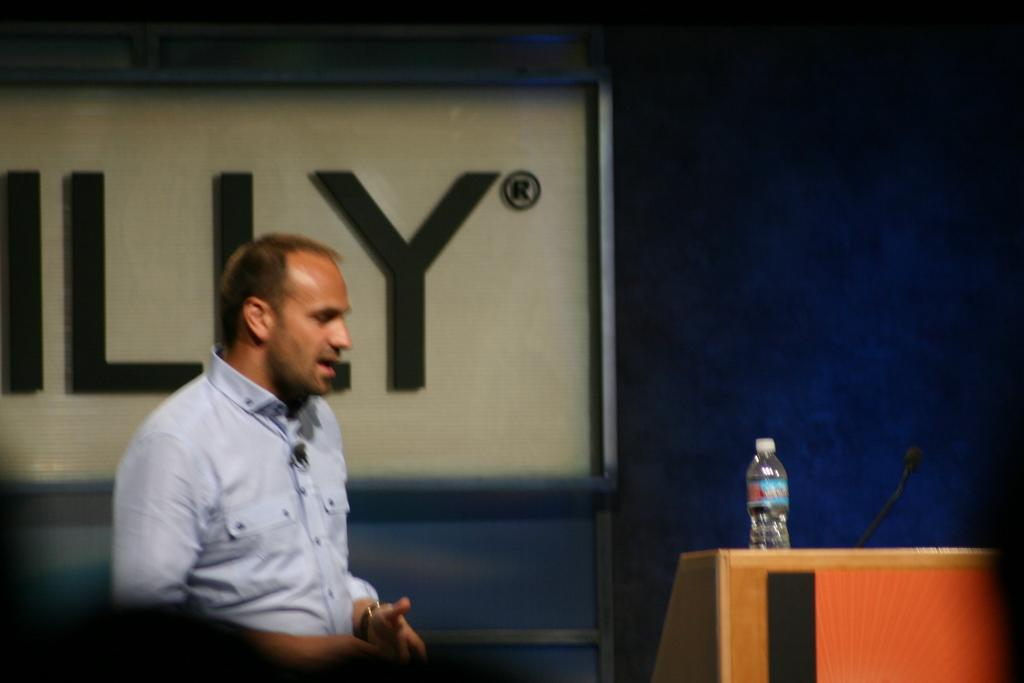What is the main subject of the image? There is a man standing in the image. What object is visible near the man? There is a water bottle in the image. What device is present in the image that is typically used for amplifying sound? There is a microphone in the image. Where is the microphone located in the image? The microphone is on a podium. What can be seen in the background of the image? There is a board in the background of the image. What is written on the board in the image? The board has text on it. What type of chalk is the tiger using to write on the board in the image? There is no tiger or chalk present in the image. How is the man using the bait to attract the audience in the image? There is no bait present in the image, and the man is not using any object to attract the audience. 